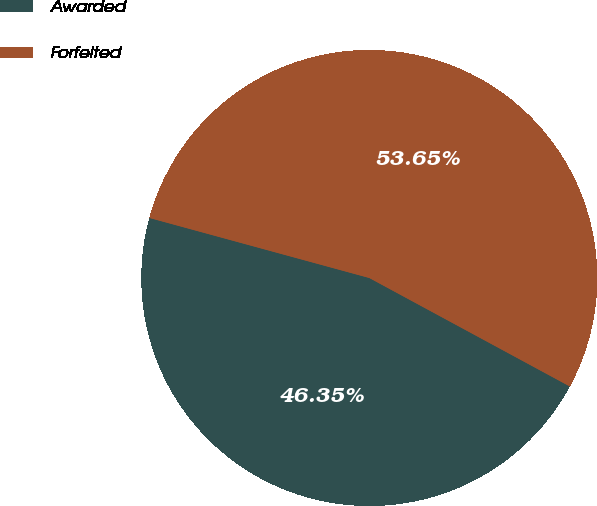Convert chart to OTSL. <chart><loc_0><loc_0><loc_500><loc_500><pie_chart><fcel>Awarded<fcel>Forfeited<nl><fcel>46.35%<fcel>53.65%<nl></chart> 